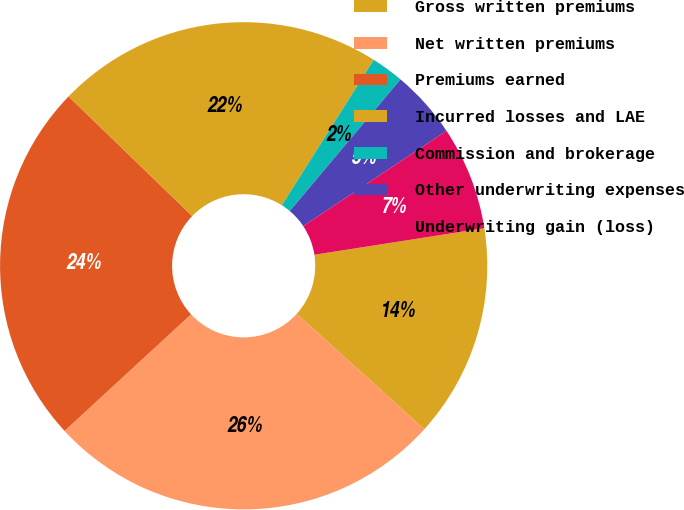Convert chart. <chart><loc_0><loc_0><loc_500><loc_500><pie_chart><fcel>Gross written premiums<fcel>Net written premiums<fcel>Premiums earned<fcel>Incurred losses and LAE<fcel>Commission and brokerage<fcel>Other underwriting expenses<fcel>Underwriting gain (loss)<nl><fcel>14.17%<fcel>26.44%<fcel>24.09%<fcel>21.73%<fcel>2.17%<fcel>4.52%<fcel>6.88%<nl></chart> 